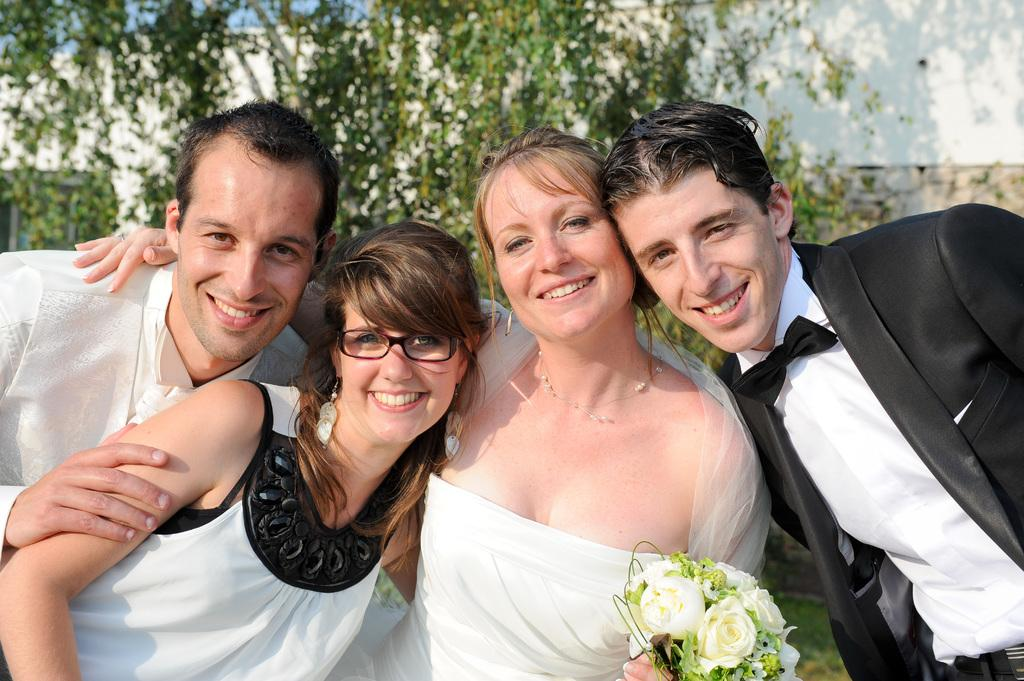How many people are present in the image? There are four people in the image. What can be seen in the background of the image? There are trees in the background of the image. What is visible at the top of the image? The sky is visible at the top of the image. What type of plant is present at the bottom of the image? There is a plant with flowers at the bottom of the image. What type of grain is being harvested by the people in the image? There is no grain present in the image, nor are the people engaged in any harvesting activity. 